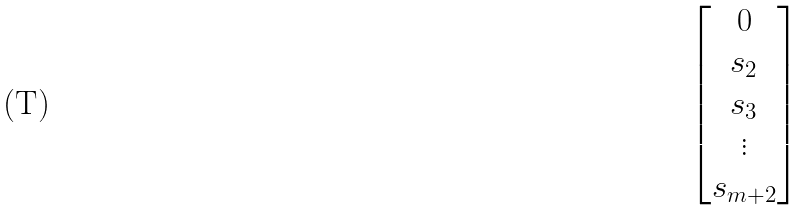<formula> <loc_0><loc_0><loc_500><loc_500>\begin{bmatrix} 0 \\ s _ { 2 } \\ s _ { 3 } \\ \vdots \\ s _ { m + 2 } \end{bmatrix}</formula> 